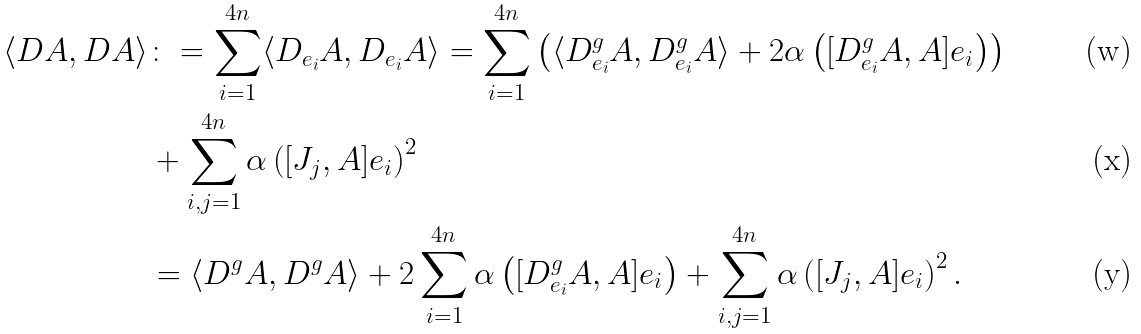<formula> <loc_0><loc_0><loc_500><loc_500>\langle D A , D A \rangle & \colon = \sum _ { i = 1 } ^ { 4 n } \langle D _ { e _ { i } } A , D _ { e _ { i } } A \rangle = \sum _ { i = 1 } ^ { 4 n } \left ( \langle D ^ { g } _ { e _ { i } } A , D ^ { g } _ { e _ { i } } A \rangle + 2 \alpha \left ( [ D ^ { g } _ { e _ { i } } A , A ] e _ { i } \right ) \right ) \\ & + \sum _ { i , j = 1 } ^ { 4 n } \alpha \left ( [ J _ { j } , A ] e _ { i } \right ) ^ { 2 } \\ & = \langle D ^ { g } A , D ^ { g } A \rangle + 2 \sum _ { i = 1 } ^ { 4 n } \alpha \left ( [ D ^ { g } _ { e _ { i } } A , A ] e _ { i } \right ) + \sum _ { i , j = 1 } ^ { 4 n } \alpha \left ( [ J _ { j } , A ] e _ { i } \right ) ^ { 2 } .</formula> 